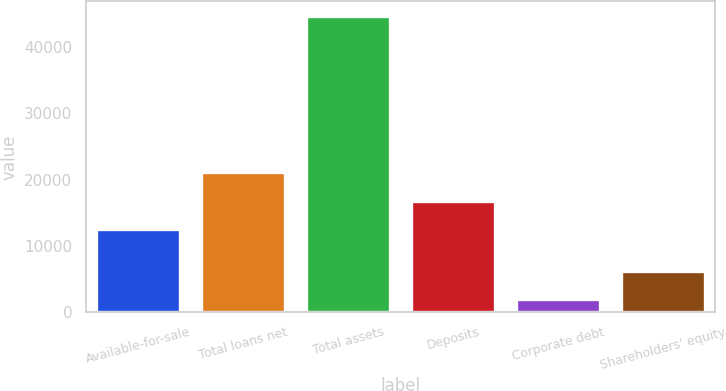<chart> <loc_0><loc_0><loc_500><loc_500><bar_chart><fcel>Available-for-sale<fcel>Total loans net<fcel>Total assets<fcel>Deposits<fcel>Corporate debt<fcel>Shareholders' equity<nl><fcel>12564.7<fcel>21073.7<fcel>44567.7<fcel>16819.2<fcel>2022.7<fcel>6277.2<nl></chart> 